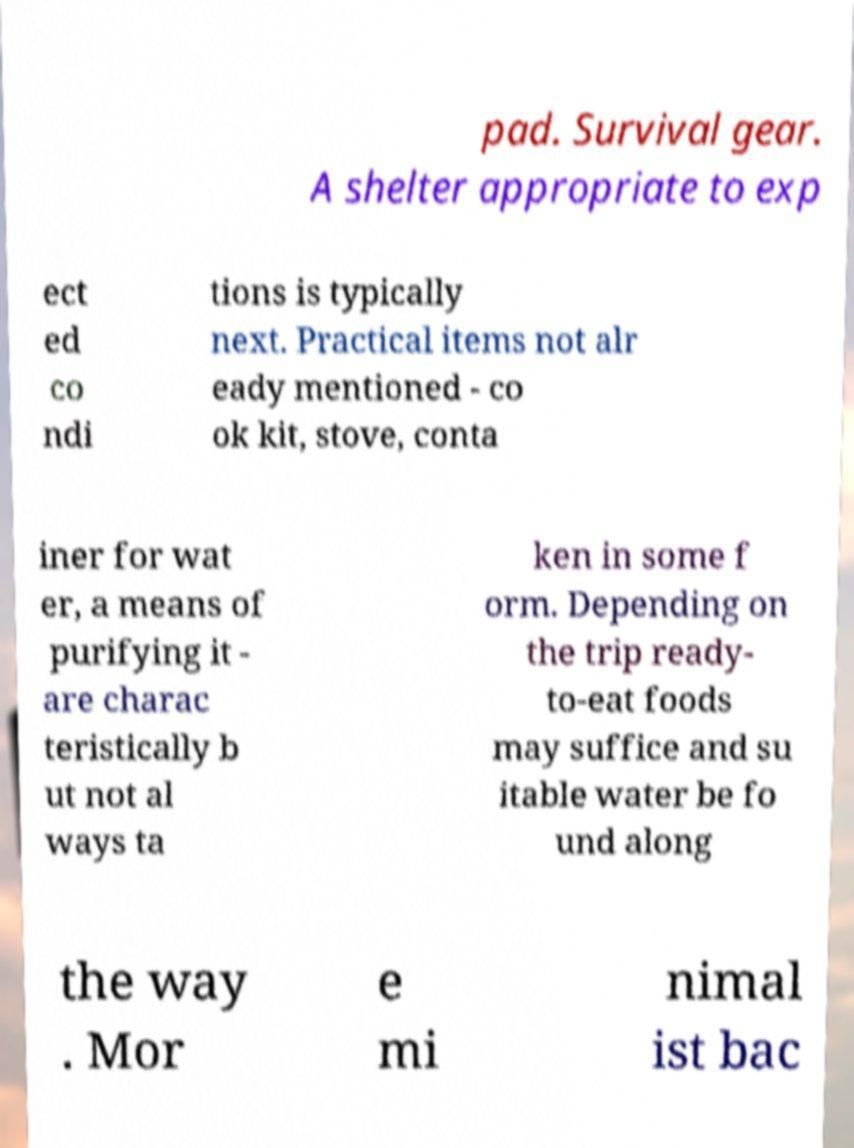What messages or text are displayed in this image? I need them in a readable, typed format. pad. Survival gear. A shelter appropriate to exp ect ed co ndi tions is typically next. Practical items not alr eady mentioned - co ok kit, stove, conta iner for wat er, a means of purifying it - are charac teristically b ut not al ways ta ken in some f orm. Depending on the trip ready- to-eat foods may suffice and su itable water be fo und along the way . Mor e mi nimal ist bac 